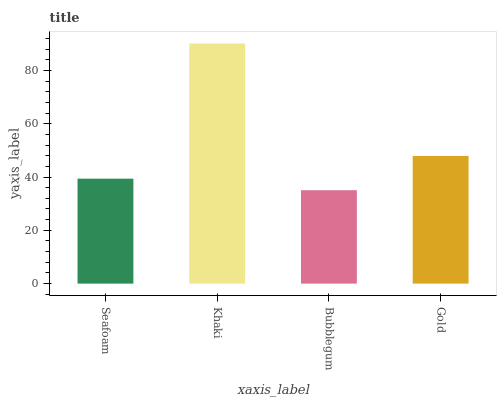Is Bubblegum the minimum?
Answer yes or no. Yes. Is Khaki the maximum?
Answer yes or no. Yes. Is Khaki the minimum?
Answer yes or no. No. Is Bubblegum the maximum?
Answer yes or no. No. Is Khaki greater than Bubblegum?
Answer yes or no. Yes. Is Bubblegum less than Khaki?
Answer yes or no. Yes. Is Bubblegum greater than Khaki?
Answer yes or no. No. Is Khaki less than Bubblegum?
Answer yes or no. No. Is Gold the high median?
Answer yes or no. Yes. Is Seafoam the low median?
Answer yes or no. Yes. Is Seafoam the high median?
Answer yes or no. No. Is Bubblegum the low median?
Answer yes or no. No. 